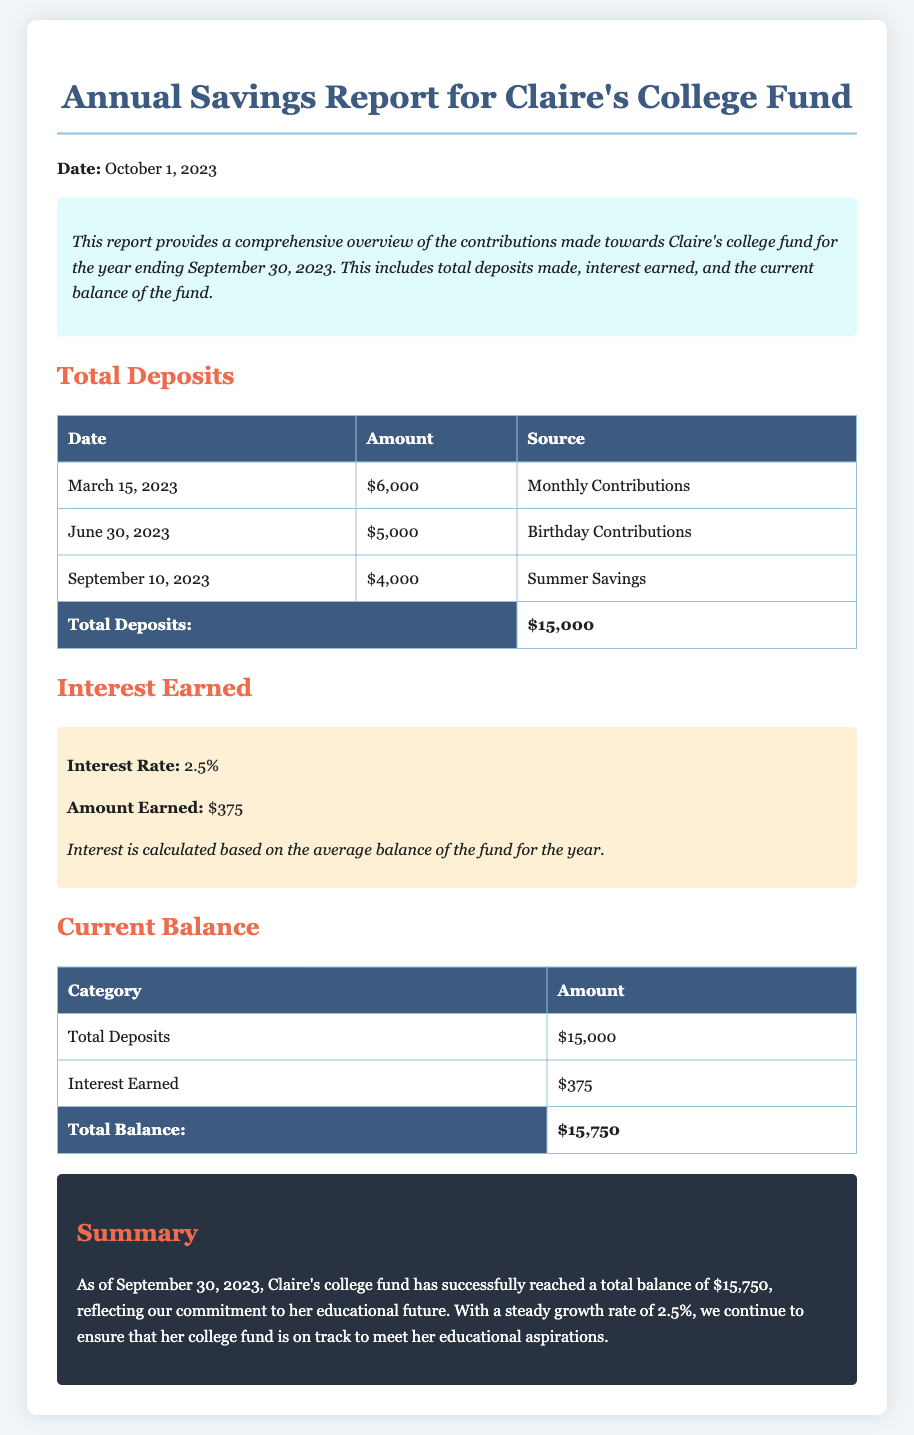What is the total amount of deposits? The total amount of deposits is clearly listed at the end of the Total Deposits table, which includes all contributions made during the year.
Answer: $15,000 How much interest was earned? The amount of interest earned is specified in the Interest Earned section of the document.
Answer: $375 What is the current balance of Claire's college fund? The current balance is summarized at the end of the Current Balance table, calculated by adding total deposits and interest earned.
Answer: $15,750 On what date was the last deposit made? The last deposit date is the most recent one in the Total Deposits table, which shows when the last contribution was received.
Answer: September 10, 2023 What was the interest rate applied to the fund? The interest rate is stated in the Interest Earned section, indicating the percentage used to calculate the earned interest.
Answer: 2.5% What category does the amount of $6,000 fall under? The amount of $6,000 is categorized under Monthly Contributions in the Total Deposits table.
Answer: Monthly Contributions How many total deposits were made? The total deposits made correspond to the number of entries in the Total Deposits table, which includes all contributions throughout the year.
Answer: 3 What is the purpose of this report? The purpose of the report is outlined in the introductory overview, summarizing the aim of the financial overview for Claire's college fund.
Answer: To provide a comprehensive overview of contributions to Claire's college fund How is interest calculated for the fund? The document notes that interest is calculated based on the average balance of the fund for the year, indicating the method used for determining earned interest.
Answer: Based on the average balance of the fund for the year 